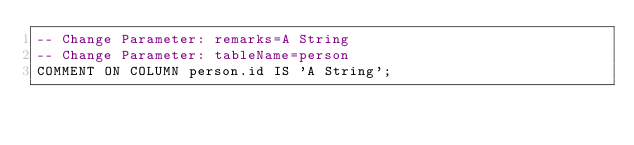<code> <loc_0><loc_0><loc_500><loc_500><_SQL_>-- Change Parameter: remarks=A String
-- Change Parameter: tableName=person
COMMENT ON COLUMN person.id IS 'A String';
</code> 